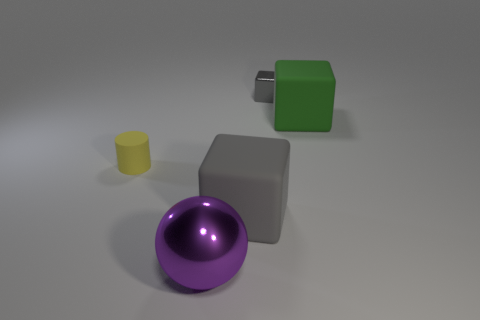Add 1 large cubes. How many objects exist? 6 Subtract all rubber blocks. How many blocks are left? 1 Subtract all blocks. How many objects are left? 2 Add 4 large cyan blocks. How many large cyan blocks exist? 4 Subtract all gray blocks. How many blocks are left? 1 Subtract 0 yellow spheres. How many objects are left? 5 Subtract 3 blocks. How many blocks are left? 0 Subtract all brown spheres. Subtract all yellow cylinders. How many spheres are left? 1 Subtract all brown cylinders. How many green cubes are left? 1 Subtract all red matte cubes. Subtract all small yellow things. How many objects are left? 4 